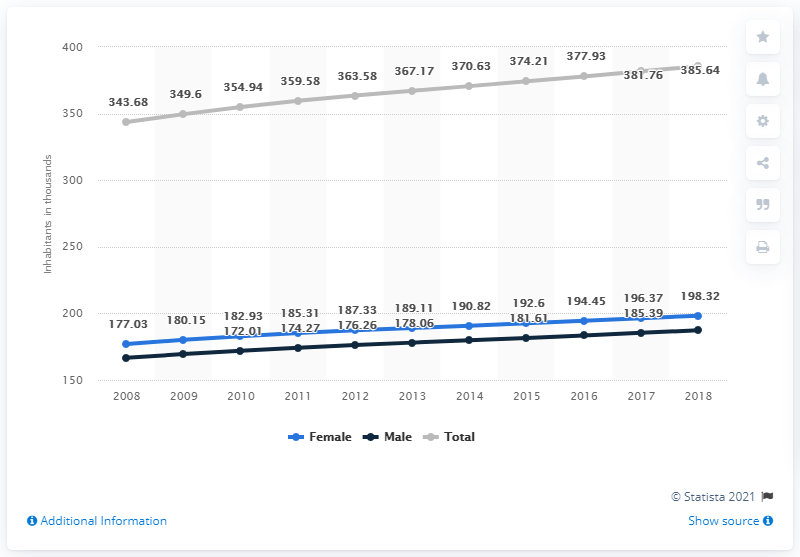Specify some key components in this picture. The female population is expected to reach its peak in 2018. The total population increased from 2016 to 2018, with a value of 7.71. The population of the Bahamas began to increase in the year 2008. 